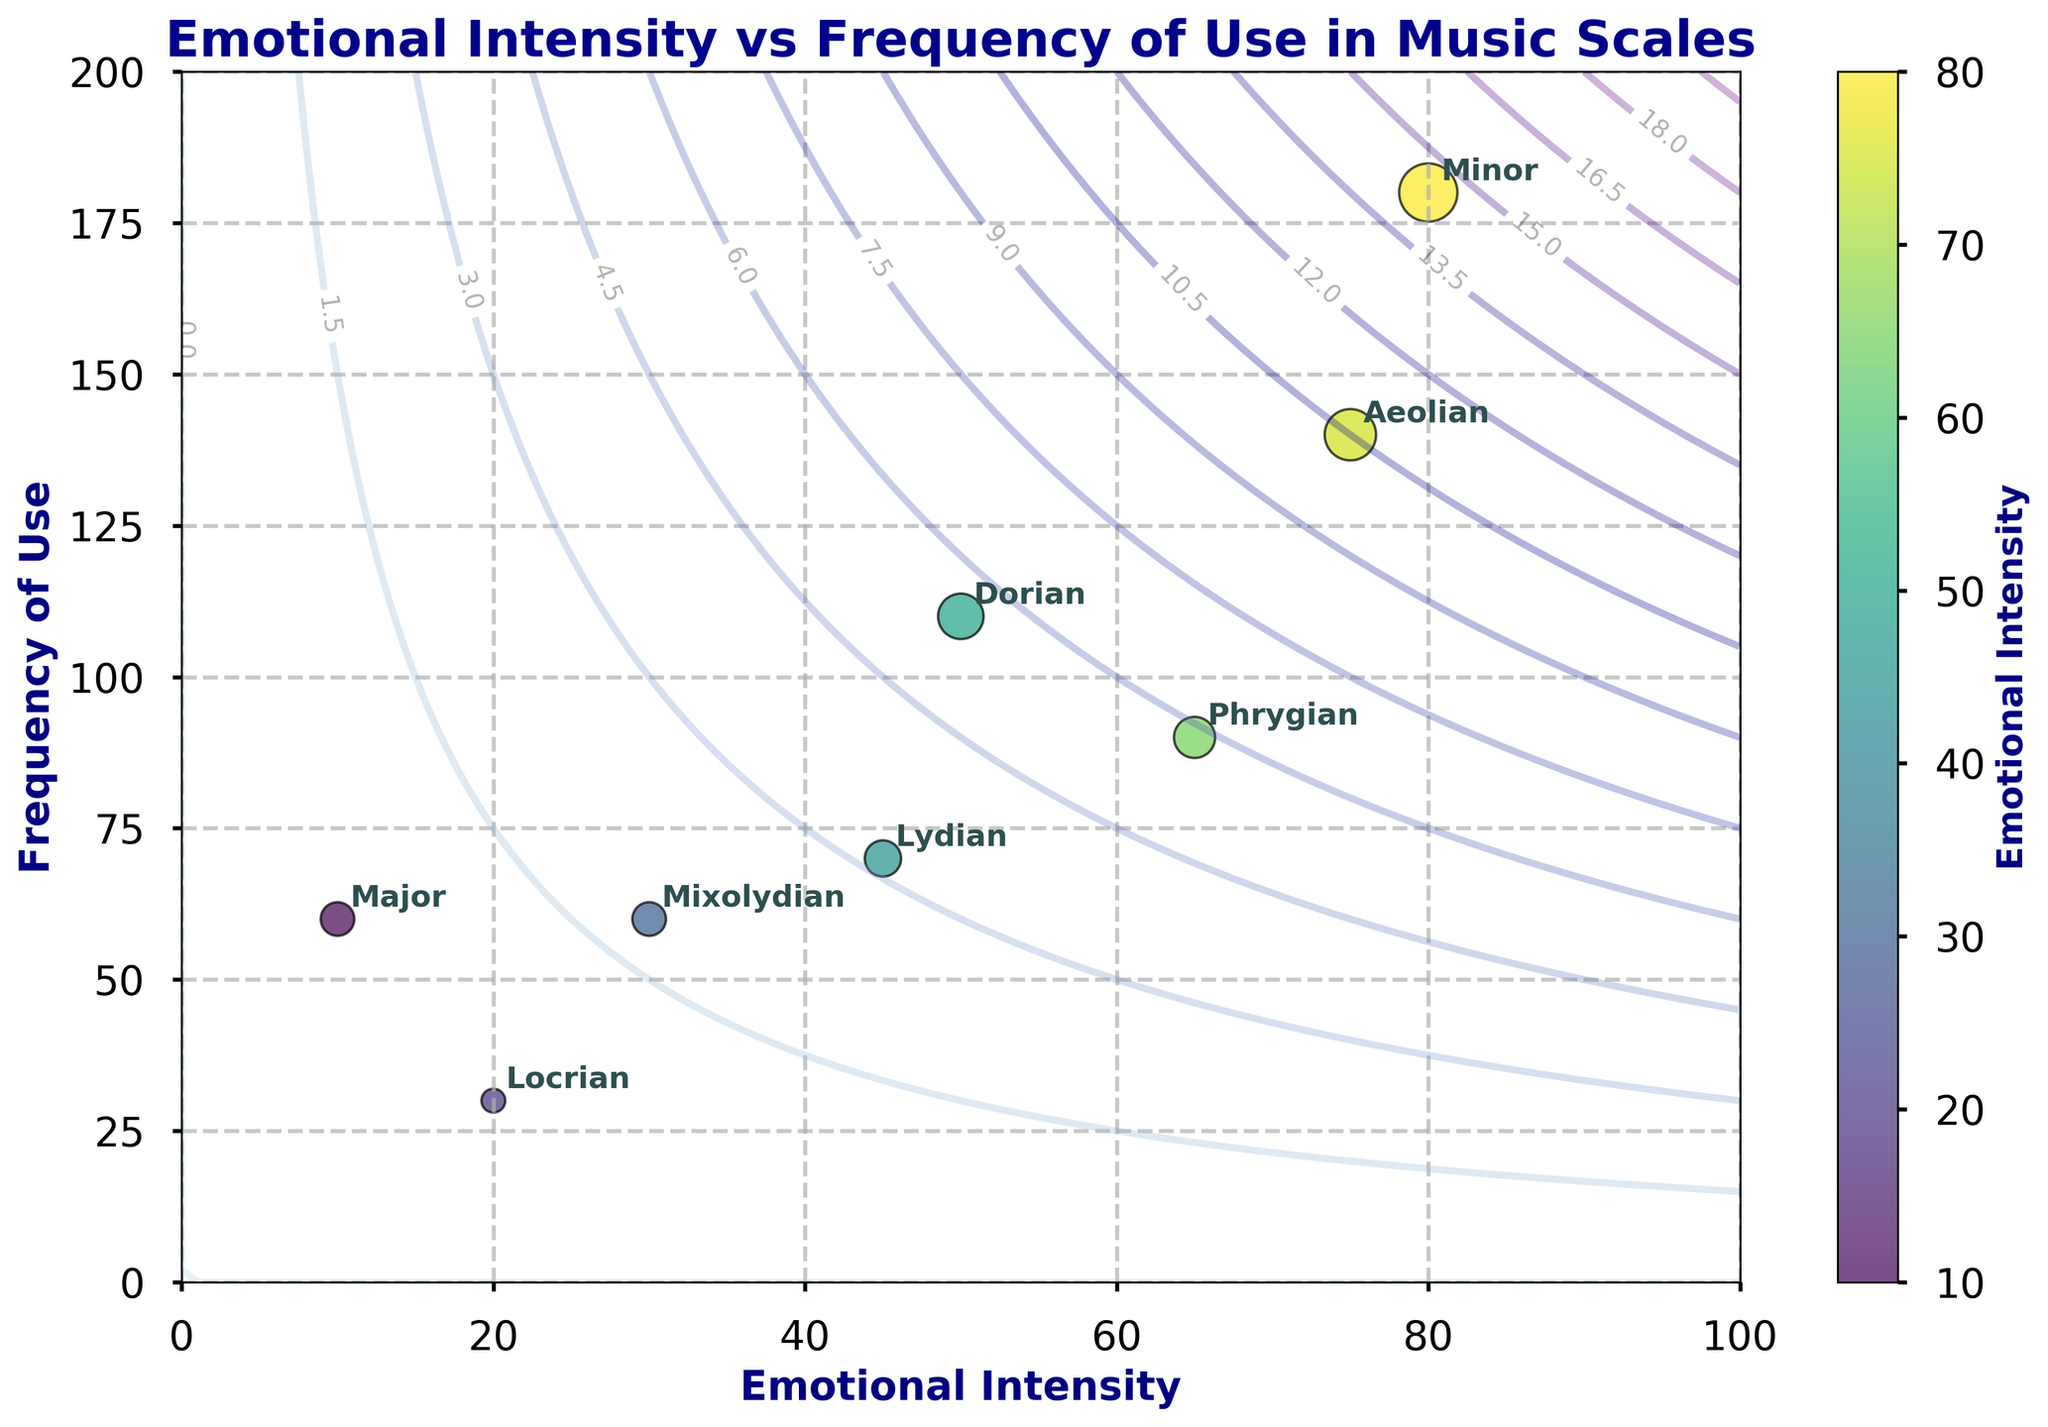what is the title of the plot? The title of the plot is shown at the top and reads "Emotional Intensity vs Frequency of Use in Music Scales."
Answer: Emotional Intensity vs Frequency of Use in Music Scales How many music scales are labeled in the plot? The plot has eight points, each labeled with the name of a music scale: Major, Minor, Dorian, Phrygian, Lydian, Mixolydian, Aeolian, and Locrian. Count the number of labels.
Answer: 8 Which scale has the highest emotional intensity? The scale with the highest emotional intensity on the x-axis is the Minor scale at 80.
Answer: Minor Between the Lydian and Phrygian scales, which one is used more frequently? From the y-axis values, Phrygian is at 90 and Lydian is at 70, so Phrygian is used more frequently.
Answer: Phrygian What is the range of emotional intensity values shown on the x-axis? The x-axis ranges from a minimum of 0 to a maximum of 100, as shown by the axis limits.
Answer: 0 to 100 Which scale, among the Major and Locrian, has a higher frequency of use? From the y-axis values, Major is at 60 and Locrian is at 30. Therefore, Major has a higher frequency of use.
Answer: Major What is the average frequency of use for the scales with emotional intensity greater than 50? Identify the scales with emotional intensity greater than 50 (Minor, Phrygian, Aeolian). Their frequencies are 180, 90, and 140. Average = (180 + 90 + 140) / 3.
Answer: 136.67 Which scale shows the lowest emotional intensity and its corresponding frequency of use? From the x-axis, Locrian has the lowest emotional intensity at 20 and its corresponding frequency of use on the y-axis is 30.
Answer: Locrian, 30 If you were to pick a median emotional intensity among all the scales, which scales fall in the middle? Arrange the emotional intensity values (10, 20, 30, 45, 50, 65, 75, 80). The median is between 45 and 50, corresponding to Lydian and Dorian.
Answer: Lydian, Dorian What does the color of the scatter points represent in the plot? The color of the scatter points represents the emotional intensity, as indicated by the color bar labeled "Emotional Intensity."
Answer: Emotional Intensity 